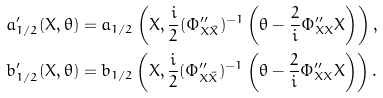<formula> <loc_0><loc_0><loc_500><loc_500>a _ { 1 / 2 } ^ { \prime } ( X , \theta ) & = a _ { 1 / 2 } \left ( X , \frac { i } { 2 } ( \Phi ^ { \prime \prime } _ { X \bar { X } } ) ^ { - 1 } \left ( \theta - \frac { 2 } { i } \Phi ^ { \prime \prime } _ { X X } X \right ) \right ) , \\ b _ { 1 / 2 } ^ { \prime } ( X , \theta ) & = b _ { 1 / 2 } \left ( X , \frac { i } { 2 } ( \Phi ^ { \prime \prime } _ { X \bar { X } } ) ^ { - 1 } \left ( \theta - \frac { 2 } { i } \Phi ^ { \prime \prime } _ { X X } X \right ) \right ) .</formula> 